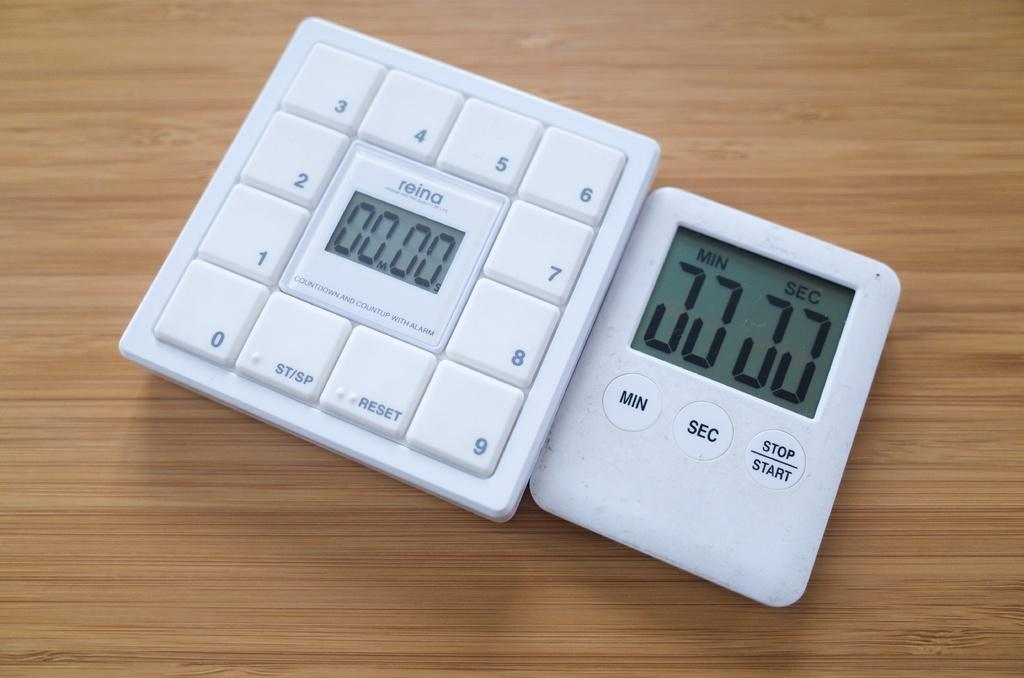<image>
Provide a brief description of the given image. A white timer and keypad that both currently read 00.00 